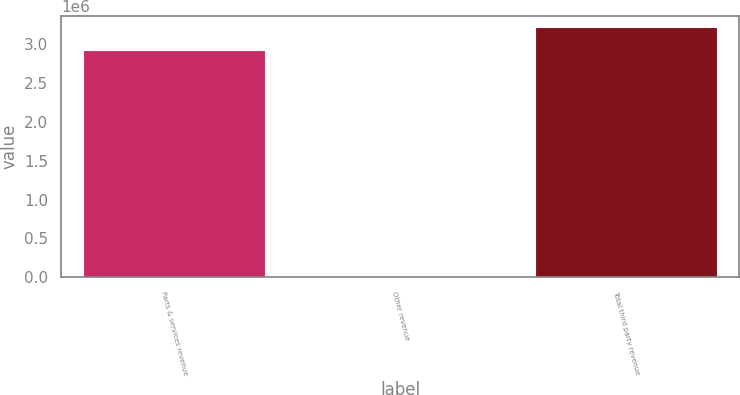<chart> <loc_0><loc_0><loc_500><loc_500><bar_chart><fcel>Parts & services revenue<fcel>Other revenue<fcel>Total third party revenue<nl><fcel>2.91584e+06<fcel>4629<fcel>3.20743e+06<nl></chart> 